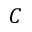<formula> <loc_0><loc_0><loc_500><loc_500>C</formula> 